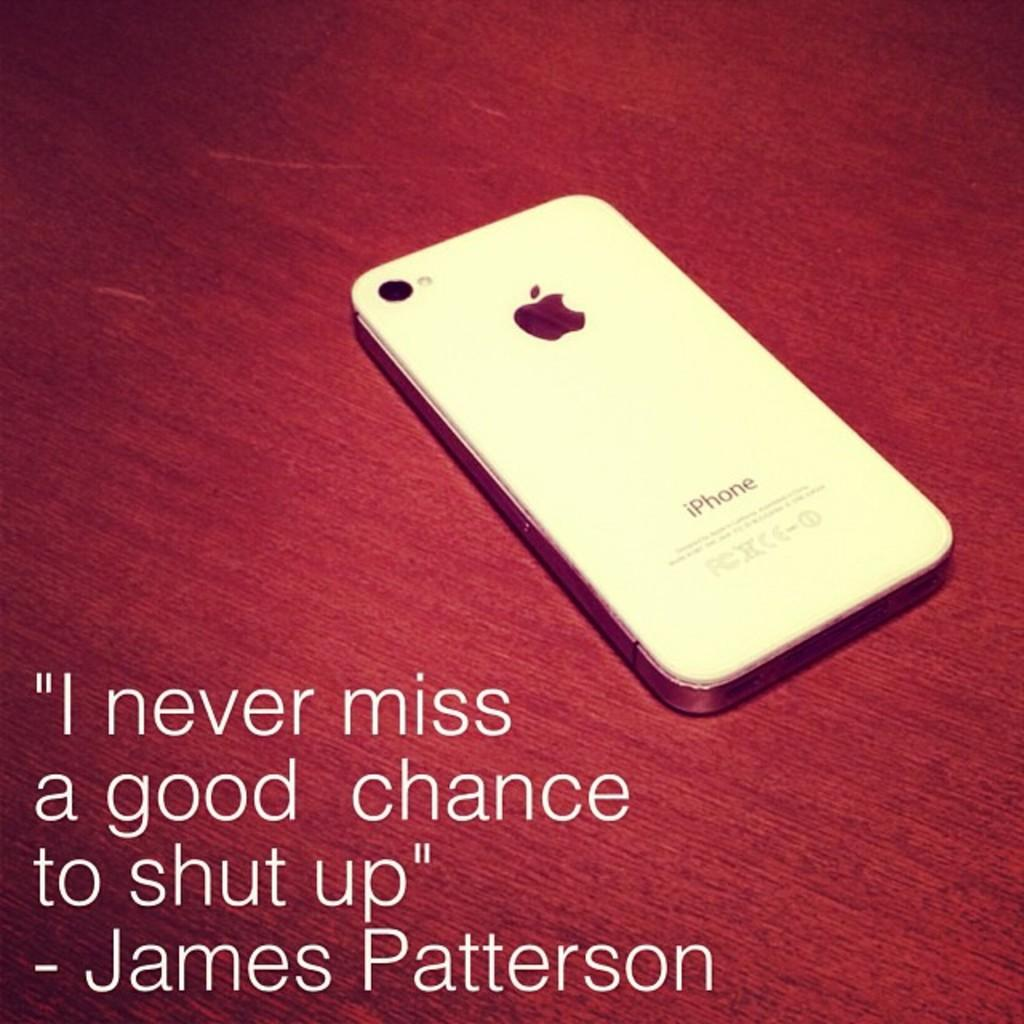<image>
Write a terse but informative summary of the picture. A white phone, imprinted iPhone, with an apple on it is laying face down on a red surface. 